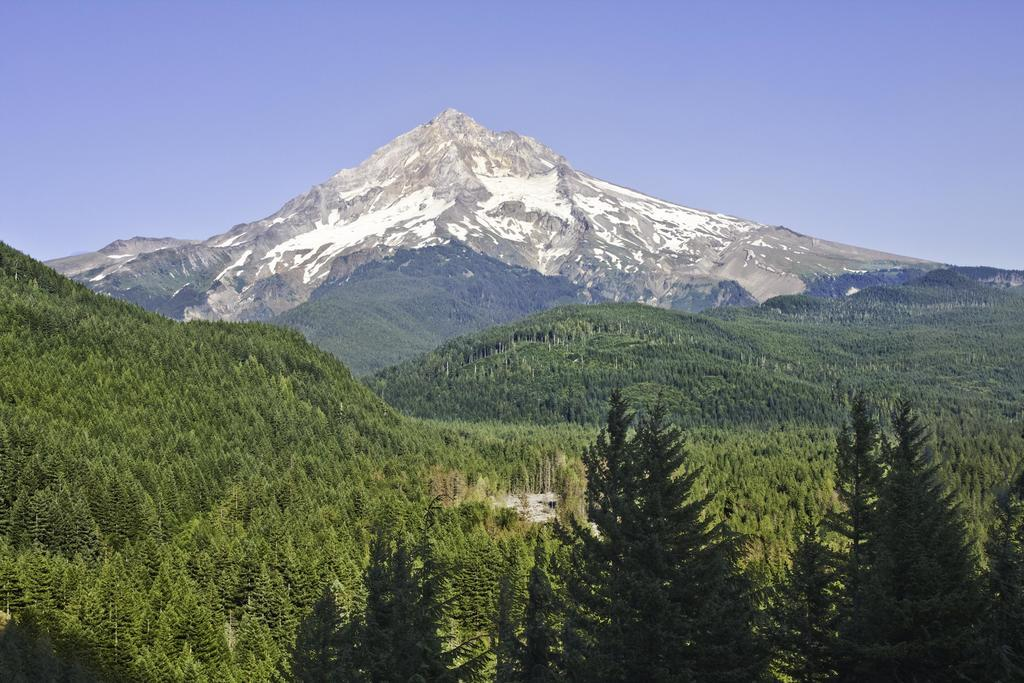What type of vegetation can be seen in the image? There are trees in the image. What natural feature is visible in the background of the image? There is a mountain in the background of the image. What part of the natural environment is visible in the image? The sky is visible in the background of the image. Can you see any horns on the trees in the image? There are no horns present on the trees in the image. Is there a coast visible in the image? There is no coast visible in the image; it features trees, a mountain, and the sky. 